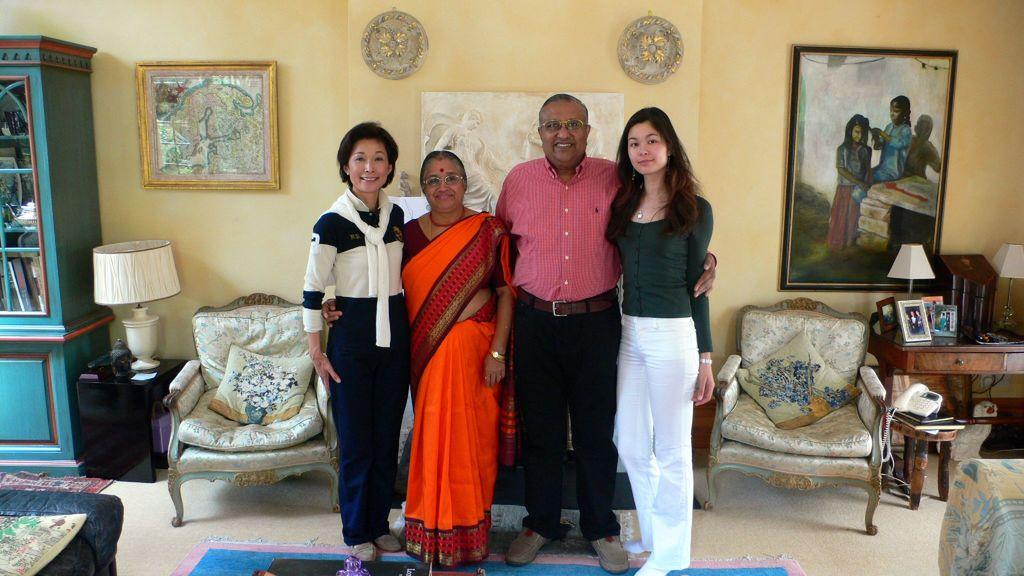How many people are in the room? There are 4 people in the room. What is the gender distribution of the people in the room? Three of the people are women, and one is a man. Where are the people standing in the room? The people are standing on the floor. What furniture or objects can be seen in the room? There is a big cupboard, a lamp, and a chair in the room. Are there any decorations on the walls? Yes, there are frames on the wall. How does the man express his pain during the rainstorm in the image? There is no mention of pain or a rainstorm in the image; it only shows 4 people standing in a room with furniture and decorations. 